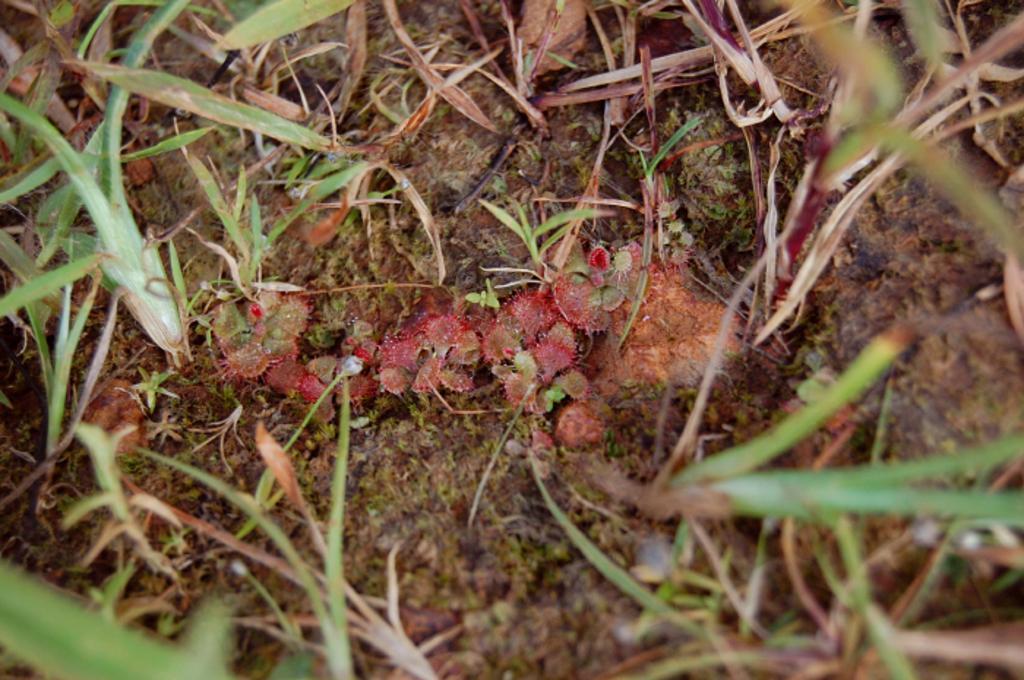Could you give a brief overview of what you see in this image? In this picture we can see plants. 